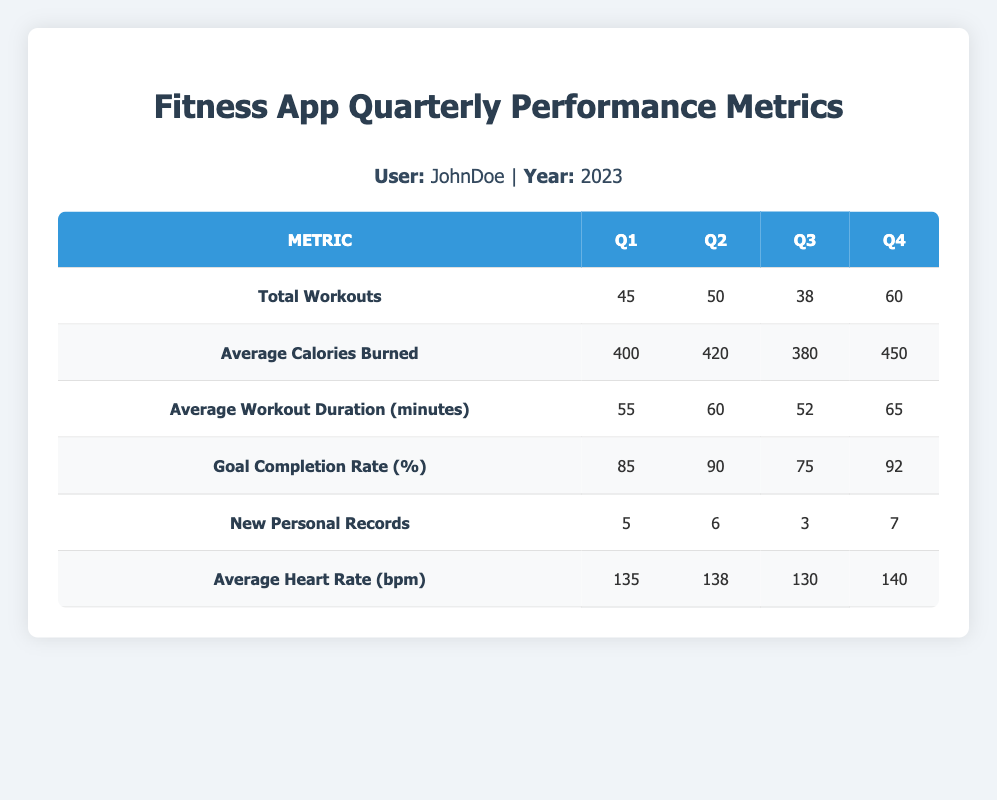What was the goal completion rate in Q3? The table explicitly provides the goal completion rate for each quarter. For Q3, it shows 75%.
Answer: 75% How many total workouts did JohnDoe complete in 2023? To find the total workouts for the year, sum the total workouts for each quarter: 45 (Q1) + 50 (Q2) + 38 (Q3) + 60 (Q4) = 193.
Answer: 193 Did JohnDoe set a new personal record in Q3? The table indicates that JohnDoe set 3 new personal records in Q3. This confirms that he did indeed set new records during that quarter.
Answer: Yes What was the average workout duration in Q4? The table lists the average workout duration for each quarter. For Q4, the average duration is 65 minutes.
Answer: 65 minutes What is the difference in the average calories burned between Q4 and Q1? From the table, average calories burned in Q4 is 450 and in Q1 is 400. The difference is 450 - 400 = 50 calories.
Answer: 50 calories What was the average heart rate in Q2 for JohnDoe? The table provides the average heart rate explicitly for Q2, which is 138 bpm.
Answer: 138 bpm How many new personal records did JohnDoe set across all quarters? By adding the numbers of new personal records for all quarters: 5 (Q1) + 6 (Q2) + 3 (Q3) + 7 (Q4) = 21.
Answer: 21 In which quarter did JohnDoe burn the most calories on average? The average calories burned were highest in Q4 at 450, as shown in the table. By comparing each quarter's average, Q4 has the highest value.
Answer: Q4 What was the trend in the total workouts from Q1 to Q3? The total workouts decreased from Q1 (45) to Q2 (50), then fell again to Q3 (38). This indicates a downward trend from Q1 to Q3.
Answer: Downward trend 